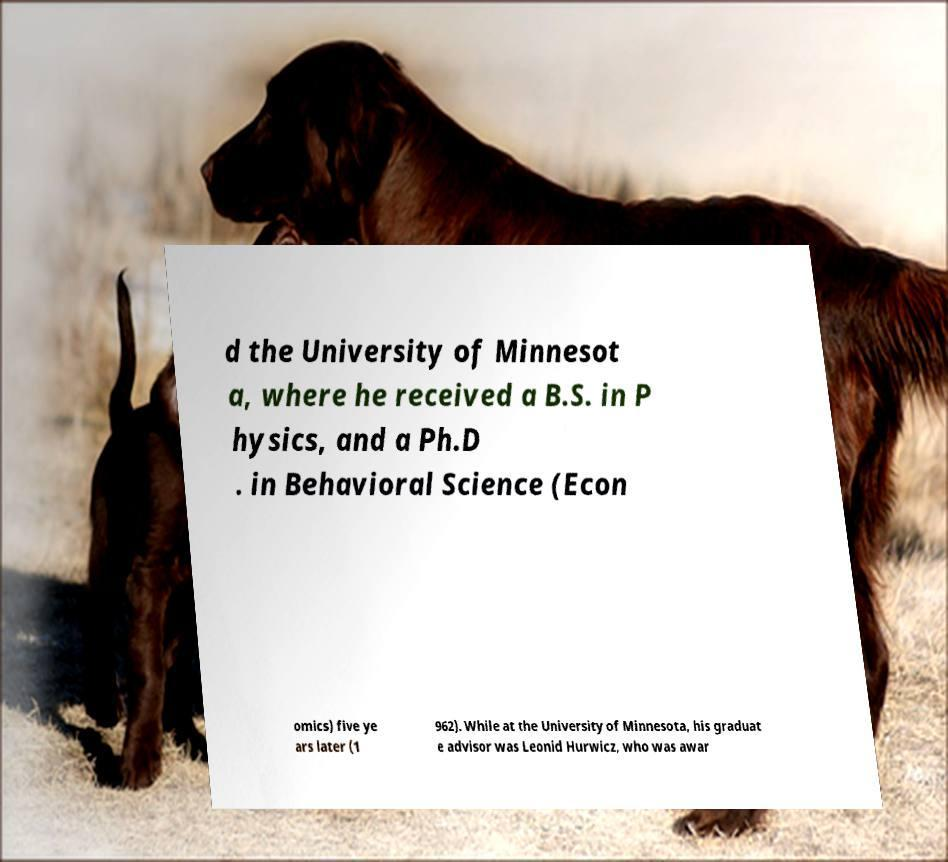Please read and relay the text visible in this image. What does it say? d the University of Minnesot a, where he received a B.S. in P hysics, and a Ph.D . in Behavioral Science (Econ omics) five ye ars later (1 962). While at the University of Minnesota, his graduat e advisor was Leonid Hurwicz, who was awar 